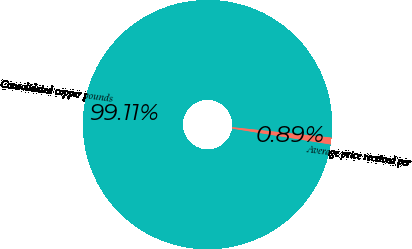Convert chart. <chart><loc_0><loc_0><loc_500><loc_500><pie_chart><fcel>Consolidated copper pounds<fcel>Average price received per<nl><fcel>99.11%<fcel>0.89%<nl></chart> 